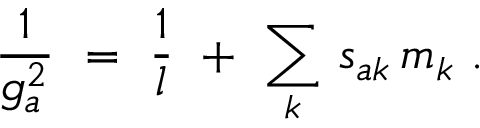Convert formula to latex. <formula><loc_0><loc_0><loc_500><loc_500>\frac { 1 } { g _ { a } ^ { 2 } } \ = \ \frac { 1 } { l } \ + \ \sum _ { k } \, s _ { a k } \, m _ { k } \ .</formula> 